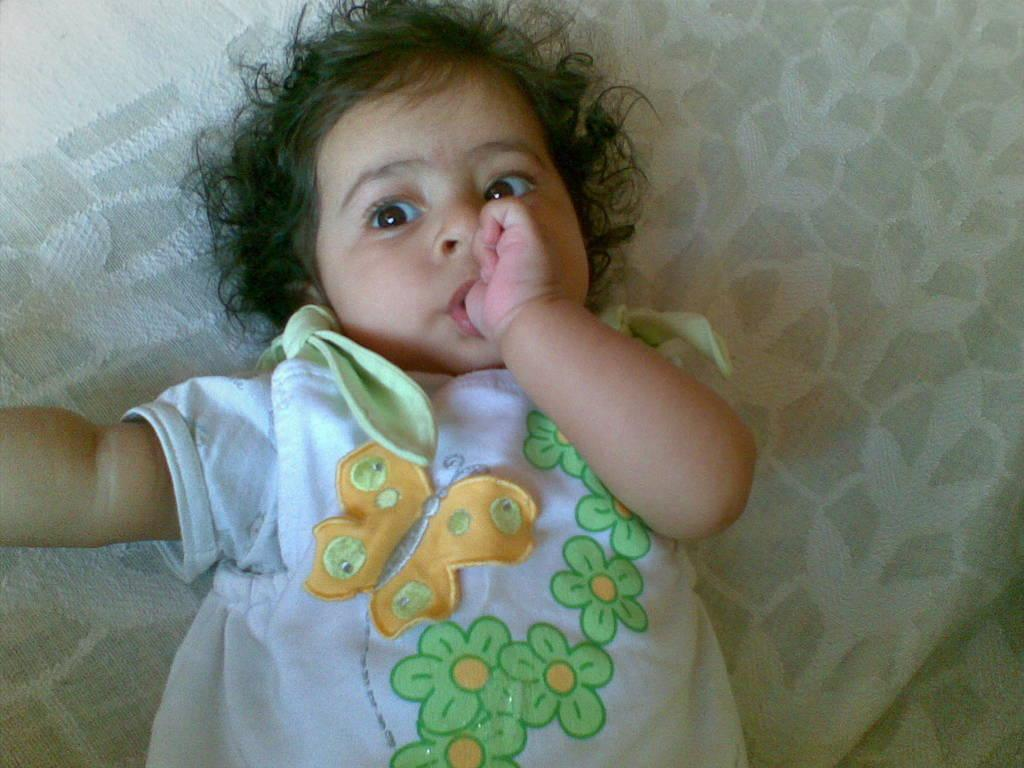What is the main subject of the image? The main subject of the image is a kid. What is the kid doing in the image? The kid is sleeping on the bed. What color is the blanket in the image? The blanket is white. What type of knowledge can be gained from the scent of the breakfast in the image? There is no mention of breakfast in the image, so it is not possible to answer a question about its scent or the knowledge that could be gained from it. 